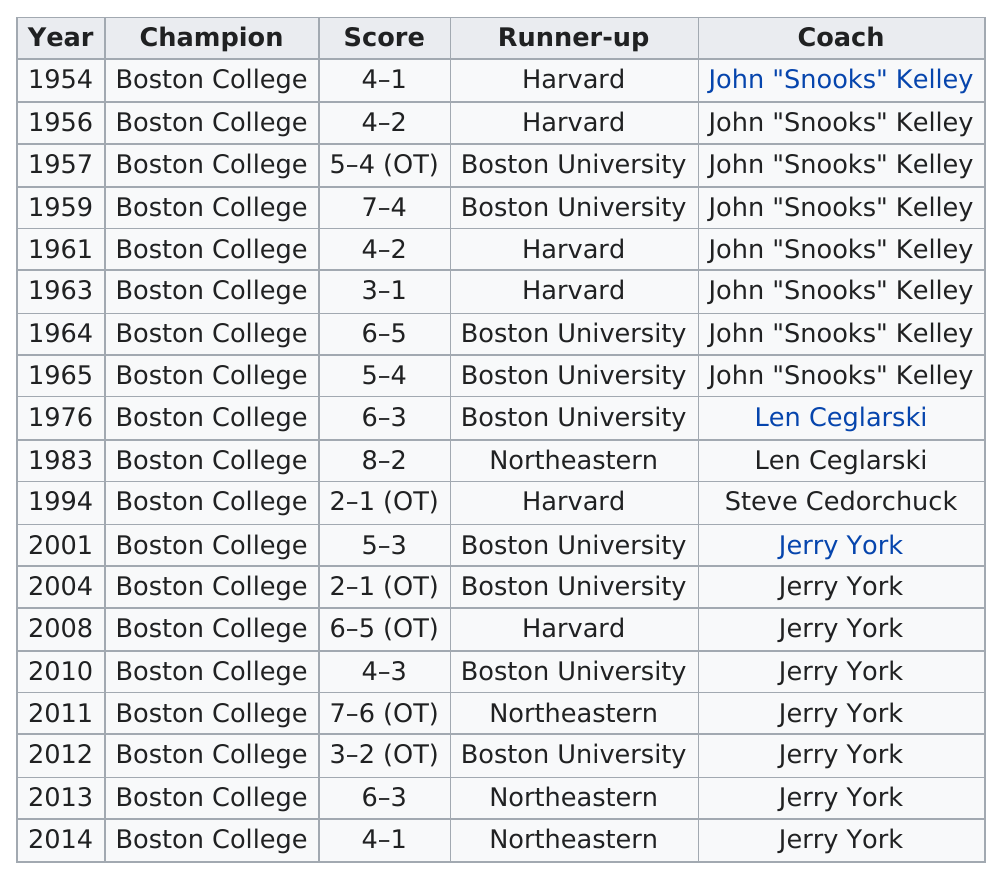Indicate a few pertinent items in this graphic. During the period between 1954 and 2014, Boston University held more runner-up positions than Harvard. In the year 1983, the largest margin of victory was recorded. Boston College did not win a NCAA Basketball Championship in the year 1954. Boston College scored more than 7 points in a game on 1 occasion. John "Snooks" Kelly and Jerry York occupied the position of head coach at Boston College. 